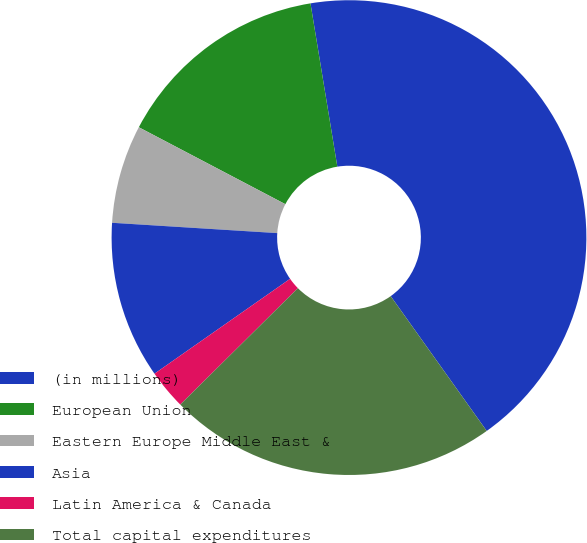<chart> <loc_0><loc_0><loc_500><loc_500><pie_chart><fcel>(in millions)<fcel>European Union<fcel>Eastern Europe Middle East &<fcel>Asia<fcel>Latin America & Canada<fcel>Total capital expenditures<nl><fcel>42.74%<fcel>14.71%<fcel>6.7%<fcel>10.71%<fcel>2.7%<fcel>22.43%<nl></chart> 